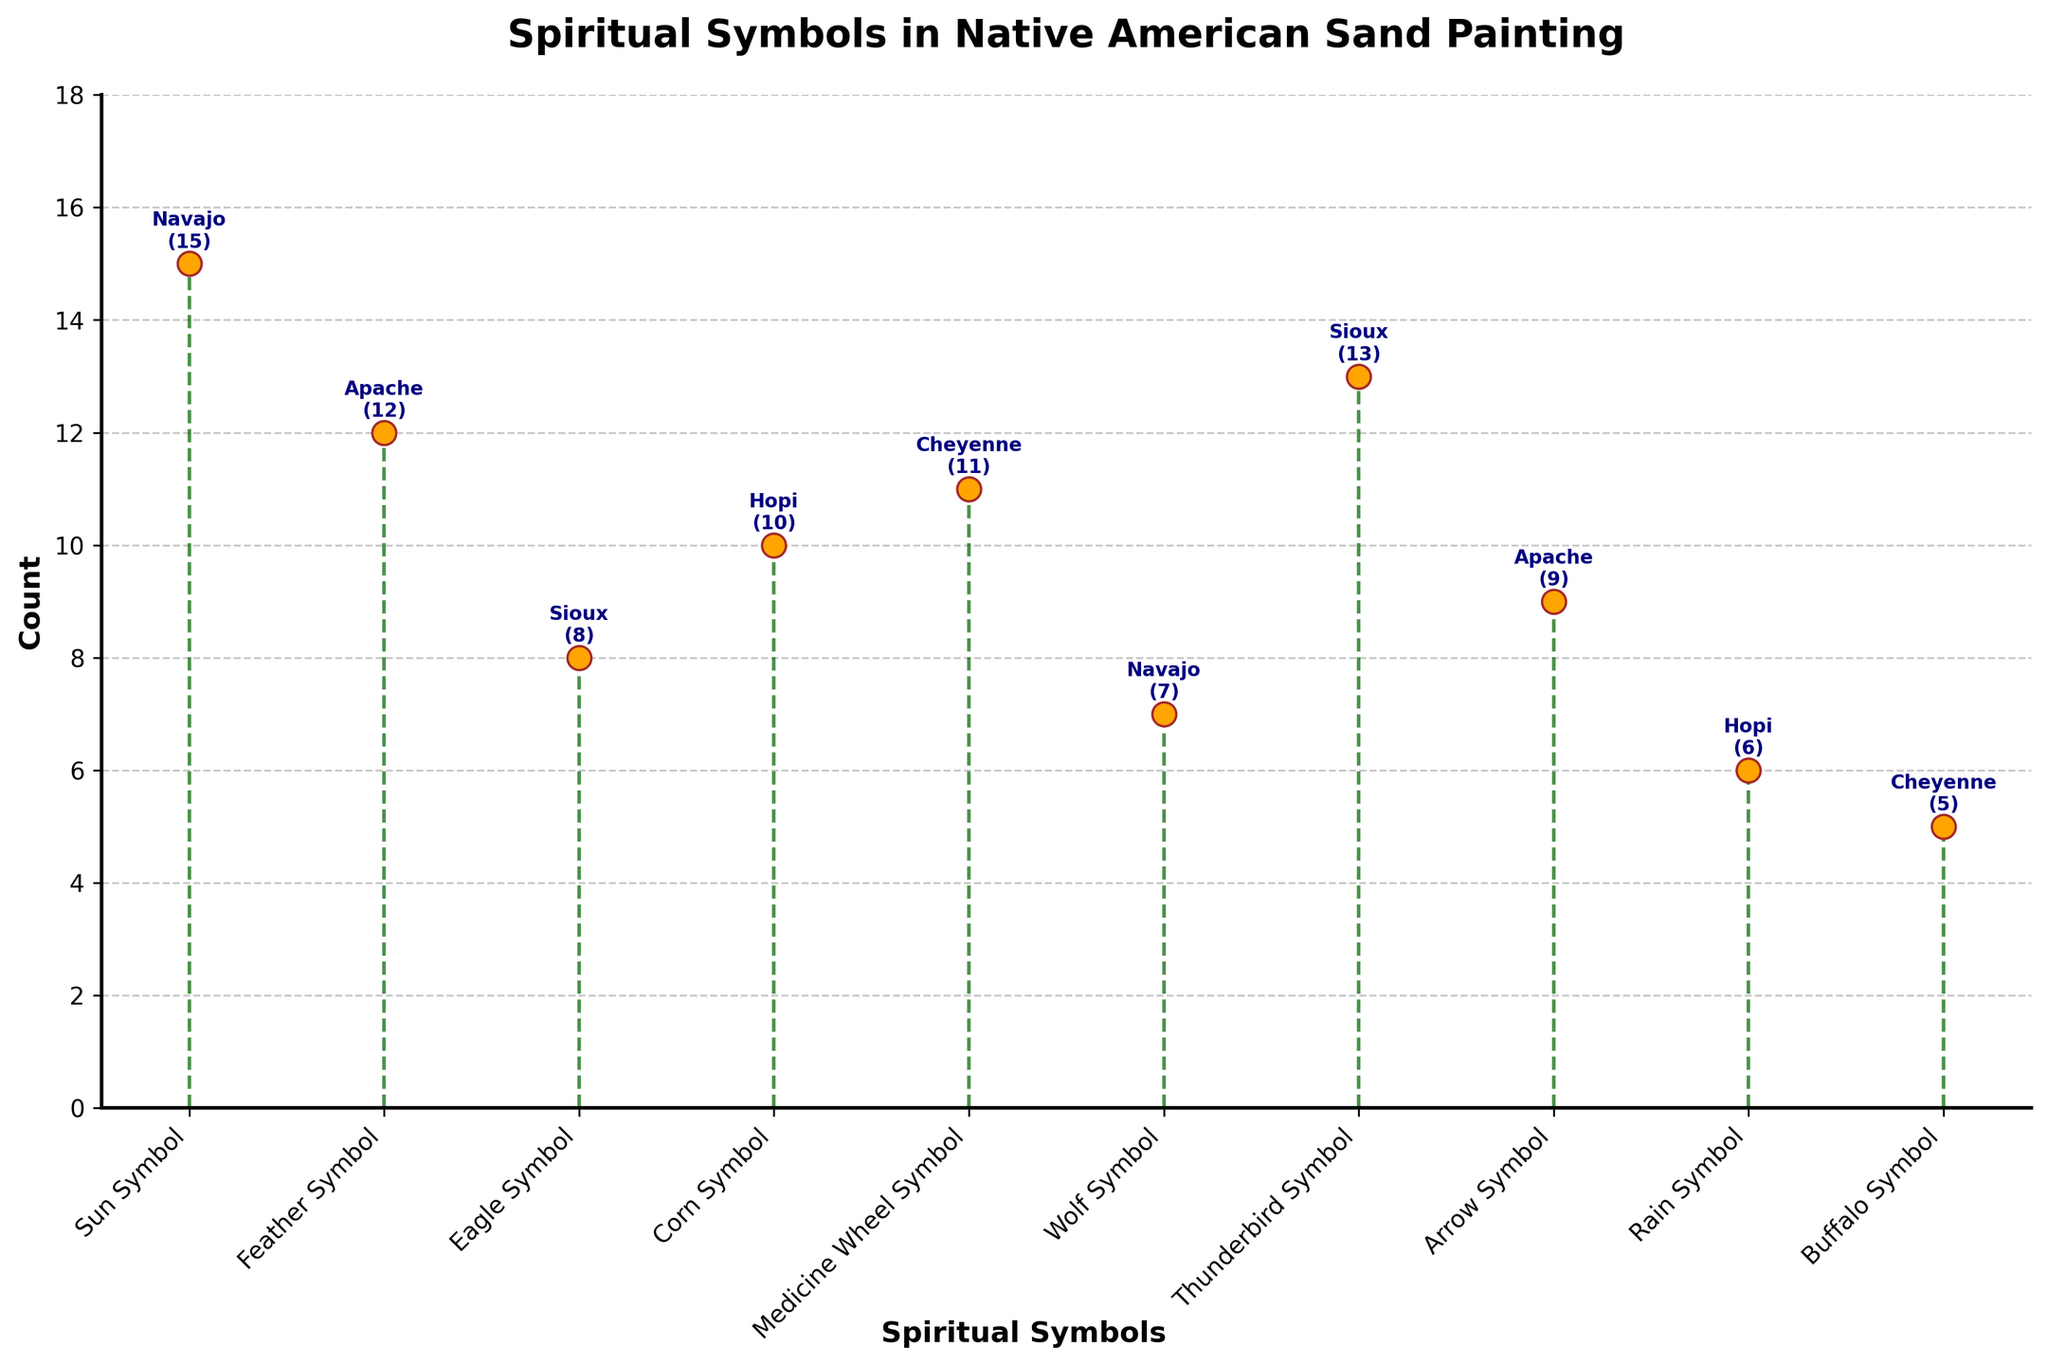What is the title of the figure? The title is usually placed at the top of the figure. It provides an overview of what the figure is about. In this case, it reads "Spiritual Symbols in Native American Sand Painting".
Answer: Spiritual Symbols in Native American Sand Painting Which symbol has the highest count and which tribe does it belong to? Look for the marker with the highest position on the y-axis. The highest marker corresponds to the "Thunderbird Symbol" for the Sioux tribe with a count of 13.
Answer: Thunderbird Symbol, Sioux What is the total count of symbols used by the Navajo tribe? Identify the markers labeled as belonging to the Navajo tribe and sum their counts. The Navajo symbols are "Sun Symbol" (15) and "Wolf Symbol" (7), so their total count is 15 + 7 = 22.
Answer: 22 Compare the counts of the Feather Symbol and the Arrow Symbol. Identify the markers for the Feather Symbol and the Arrow Symbol and compare their counts. The Feather Symbol (Apache) has a count of 12, while the Arrow Symbol (Apache) has a count of 9.
Answer: The Feather Symbol count is higher by 3 Which symbol has the lowest count and what is its value? Find the marker with the lowest position on the y-axis. The lowest marker corresponds to the "Buffalo Symbol" for the Cheyenne tribe with a count of 5.
Answer: Buffalo Symbol, 5 What are the counts for symbols used by the Hopi tribe? Identify the markers labeled as belonging to the Hopi tribe and note their counts. The Hopi symbols are "Corn Symbol" (10) and "Rain Symbol" (6).
Answer: 10 and 6 How many symbols have a count greater than 10? Look at the markers and count those which have a position above the y-axis value of 10. These are "Sun Symbol" (15), "Feather Symbol" (12), and "Thunderbird Symbol" (13). There are three such symbols.
Answer: 3 What is the difference in count between the Sun Symbol and the Wolf Symbol for the Navajo tribe? Identify the counts for the Sun Symbol (15) and Wolf Symbol (7) and calculate the difference, which is 15 - 7 = 8.
Answer: 8 Which tribes have more than one symbol represented in the figure? Look at the labels attached to each marker and identify tribes mentioned more than once. The tribes with multiple symbols are Navajo, Apache, Hopi, and Sioux.
Answer: Navajo, Apache, Hopi, Sioux What is the average count of all symbols? Sum all the counts and divide by the number of symbols. The counts are [15, 12, 8, 10, 11, 7, 13, 9, 6, 5]. The total is 96 and there are 10 symbols, so the average is 96 / 10 = 9.6.
Answer: 9.6 